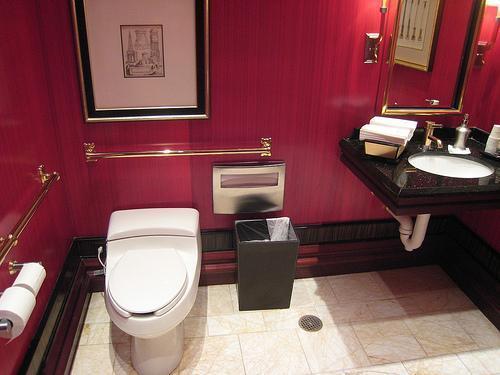How many toilets are in the photo?
Give a very brief answer. 1. 